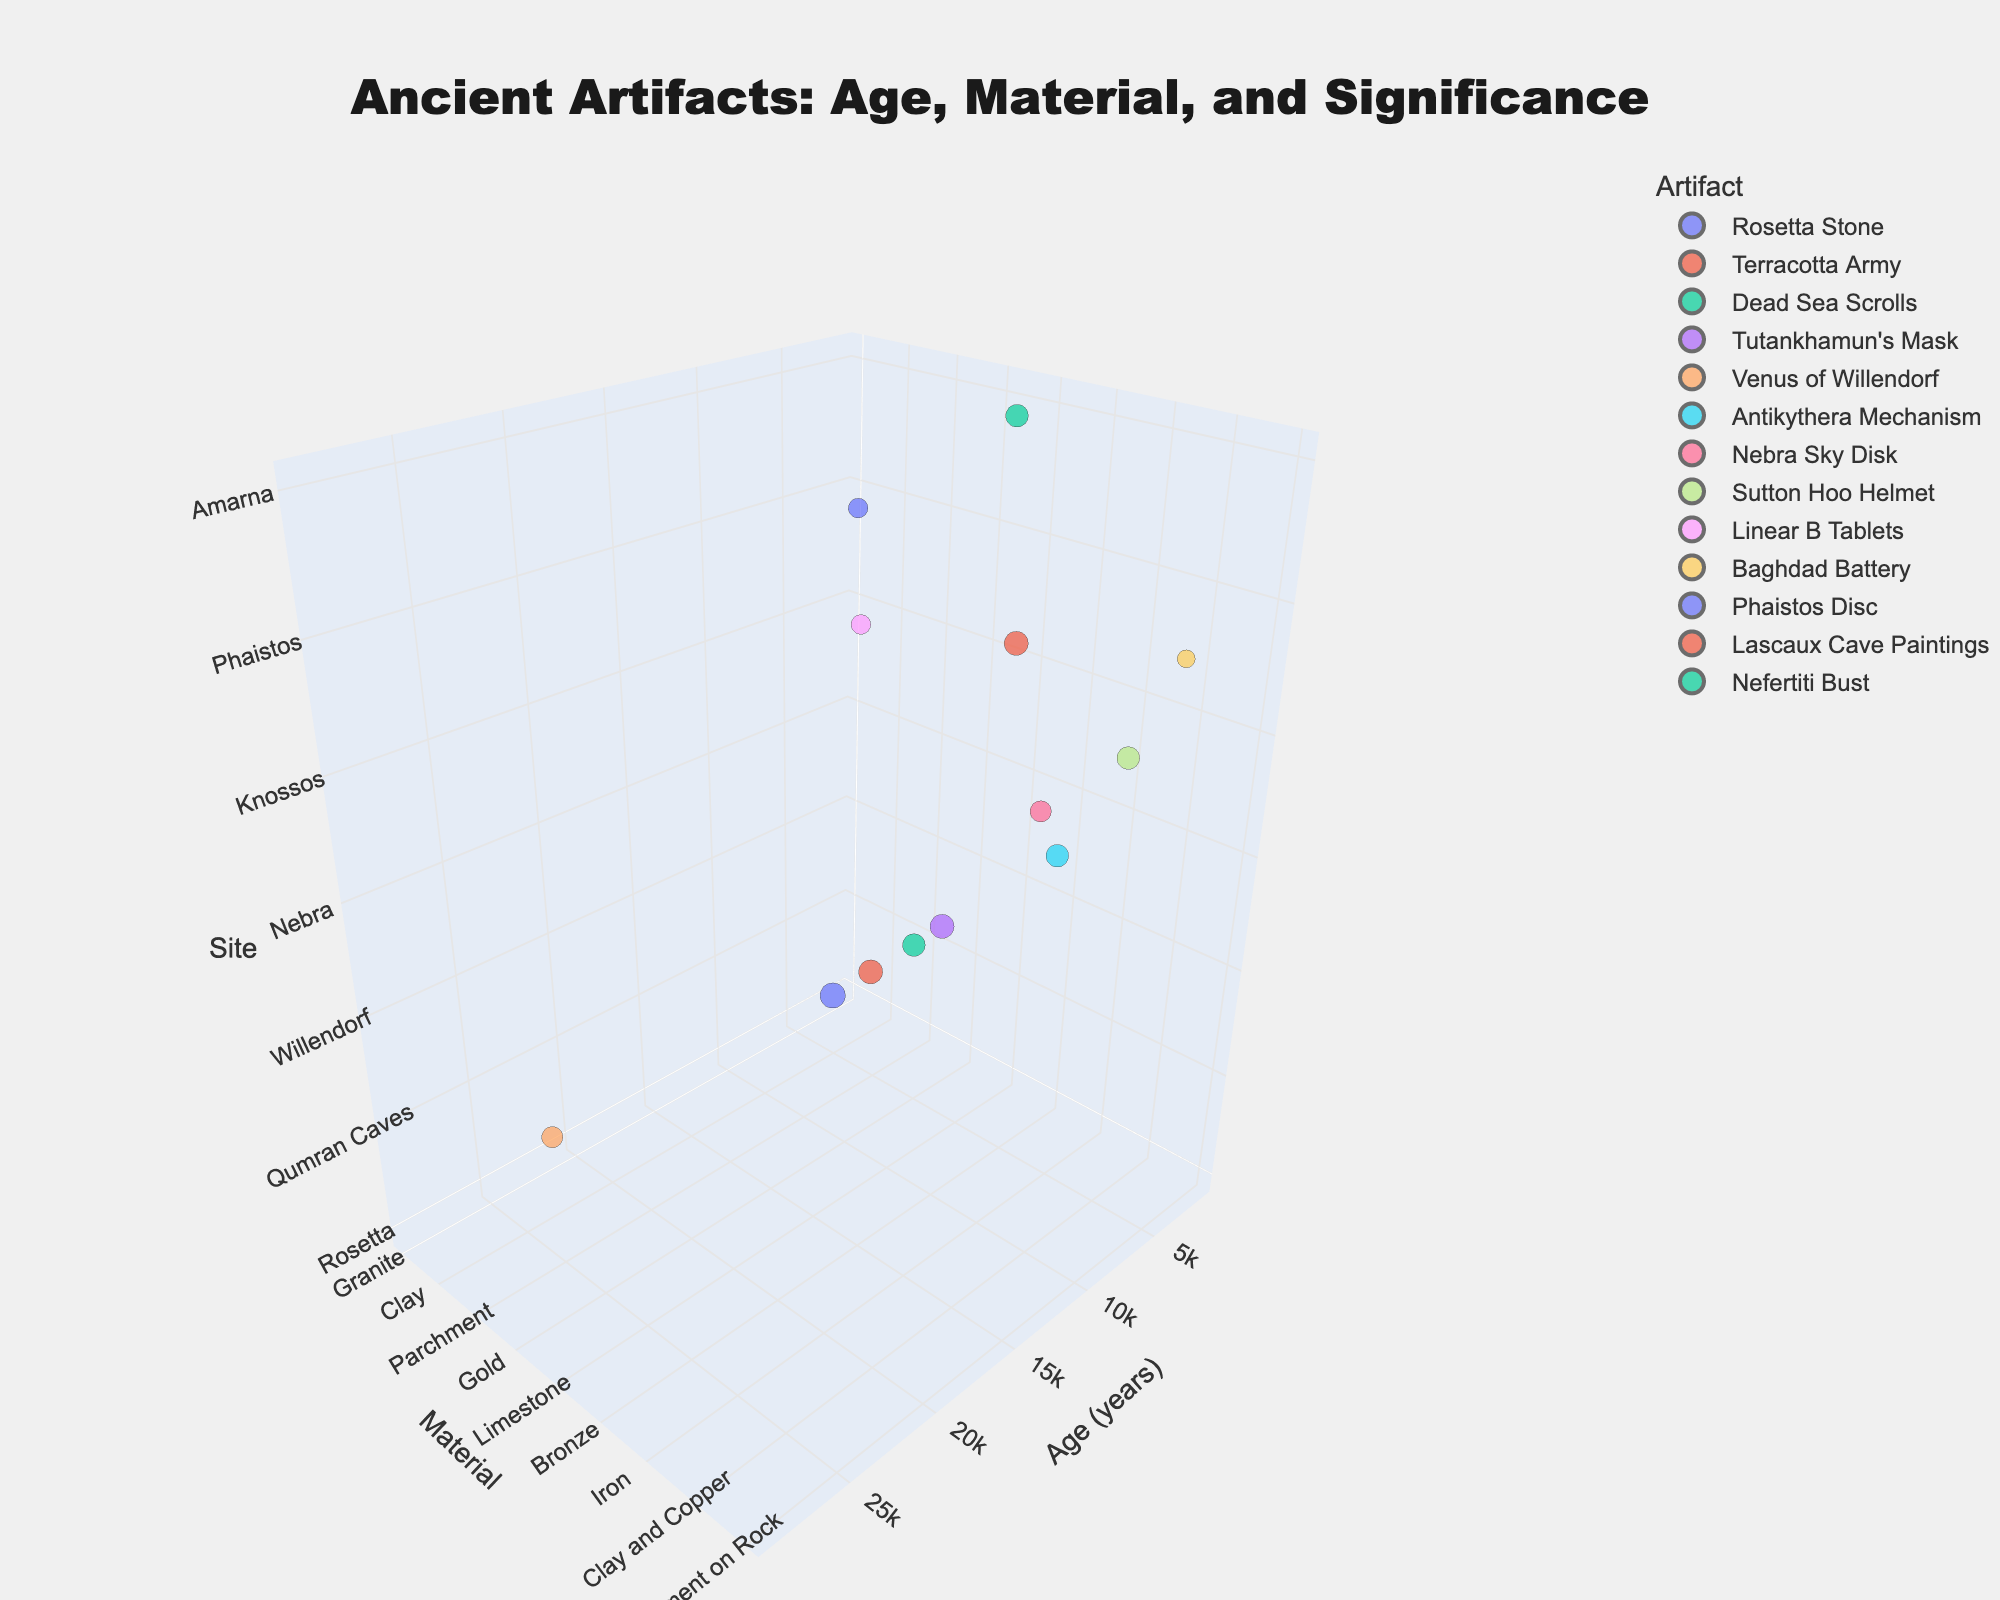What is the title of the chart? The title is usually one of the most visible elements at the top of the chart. It provides a summary of what the chart is about.
Answer: Ancient Artifacts: Age, Material, and Significance How many artifacts are plotted in the chart? By counting each distinct bubble that represents an artifact on the chart, we can determine the total number of artifacts plotted.
Answer: 12 Which artifact is the most significant according to the chart? To determine the most significant artifact, look for the bubble with the largest size as it represents significance. In this case, the Rosetta Stone has the highest significance value of 10.
Answer: Rosetta Stone Which artifact is the oldest and what material is it made of? The oldest artifact is determined by looking at the position on the x-axis (Age in years). The furthest point corresponds to the oldest age. In this chart, the Venus of Willendorf, made of limestone, is the oldest artifact.
Answer: Venus of Willendorf, Limestone What is the average age of all the artifacts shown in the chart? To find the average age, sum all the ages of the artifacts and then divide by the number of artifacts. The sum of ages (2200 + 2250 + 2100 + 3300 + 29000 + 2100 + 3600 + 1400 + 3400 + 2200 + 3700 + 17000 + 3350) = 122600 and there are 12 artifacts. So, 122600 / 12 = 10216.67
Answer: 10216.67 years Which site has both high significance and young age artifacts? To answer this, look for bubbles that are large in size (high significance) and closer to the left of the x-axis (younger age). The Rosetta Stone and the Baghdad Battery in their respective sites (Rosetta and Khujut Rabu) fit this criterion.
Answer: Rosetta Stone (Rosetta), Baghdad Battery (Khujut Rabu) What is the most common material among the artifacts? By identifying the material of each artifact and counting the frequency of each, we see that clay is the most common material, appearing in multiple artifacts (Terracotta Army, Linear B Tablets, Baghdad Battery, Phaistos Disc).
Answer: Clay How much older is the Nefertiti Bust compared to the Rosetta Stone? To find out the difference in ages, subtract the age of the Rosetta Stone from the age of the Nefertiti Bust. The age of the Nefertiti Bust is 3350 years, and the Rosetta Stone is 2200 years. 3350 - 2200 = 1150
Answer: 1150 years Which artifact's material is unique among the artifacts plotted in the chart? A unique material is one that is not repeated for any other artifact. The parchment of the Dead Sea Scrolls or the Pigment on Rock of the Lascaux Cave Paintings are unique materials in the data.
Answer: Dead Sea Scrolls (Parchment), Lascaux Cave Paintings (Pigment on Rock) Compare the artifacts from the Valley of the Kings and Amarna in terms of their material and age. Locate the artifacts Tutankhamun's Mask (Valley of the Kings) and Nefertiti Bust (Amarna) on the chart. Tutankhamun's Mask is made of gold and is 3300 years old. Nefertiti Bust is made of limestone and is 3350 years old. So, while the materials are different, their ages are nearly identical.
Answer: Tutankhamun's Mask: Gold, 3300 years; Nefertiti Bust: Limestone, 3350 years 